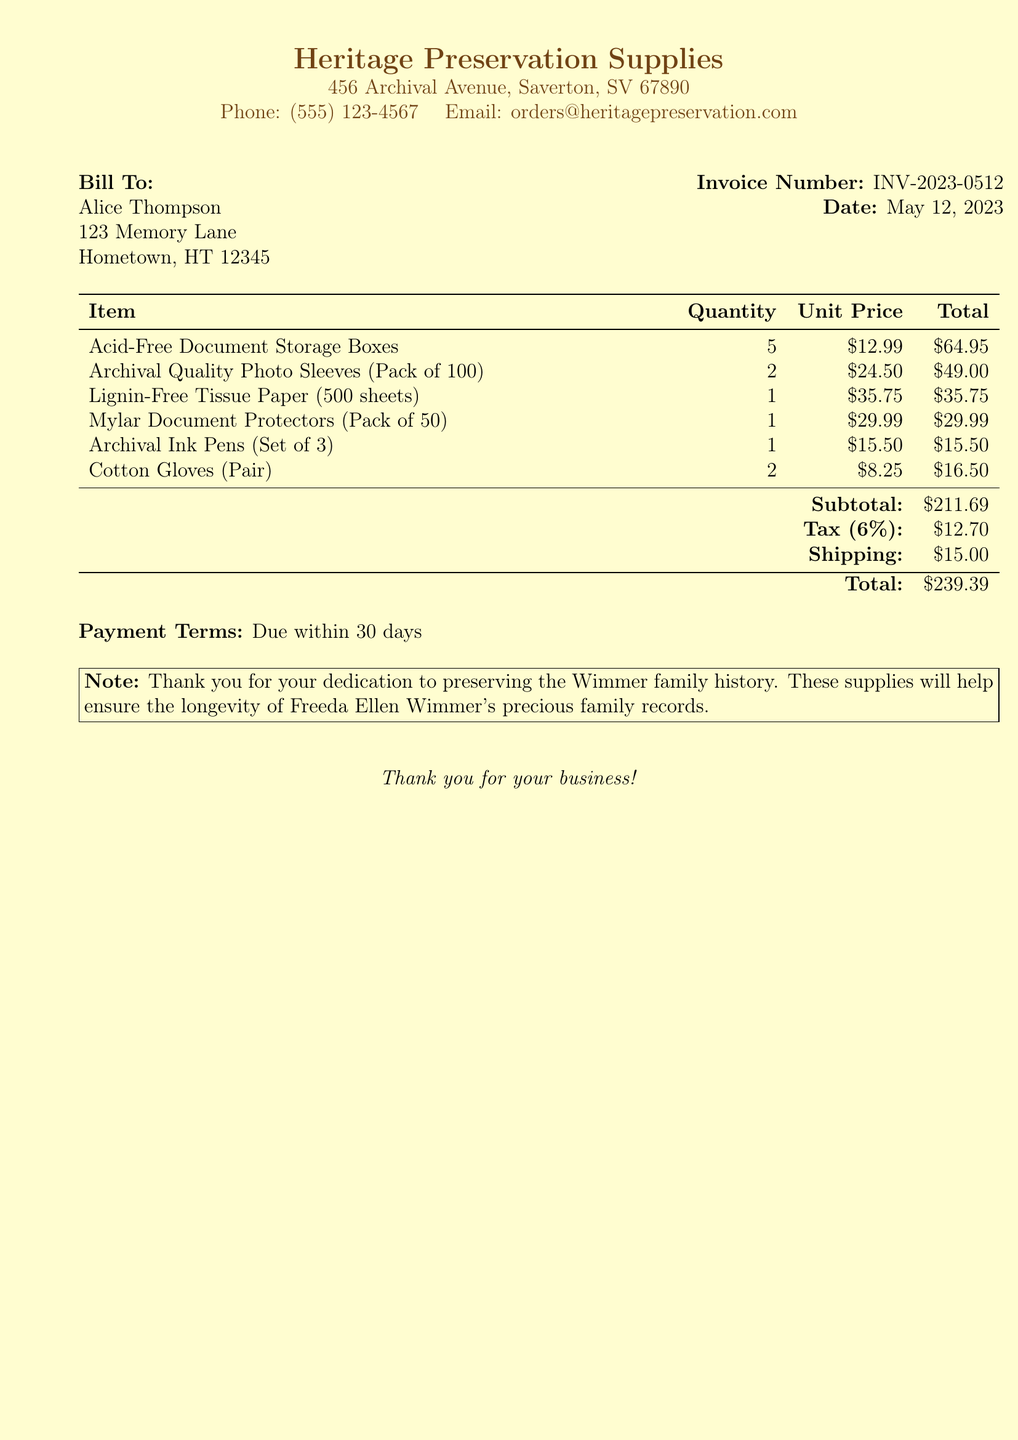What is the invoice number? The invoice number is clearly listed in the document's header section.
Answer: INV-2023-0512 What is the date of the invoice? The date is indicated next to the invoice number in the header section of the document.
Answer: May 12, 2023 Who is the bill to? The document specifies the name and address of the person being billed at the beginning.
Answer: Alice Thompson What is the total amount due? The total amount is calculated at the bottom of the itemized list and includes all fees.
Answer: $239.39 How many cotton gloves were ordered? The quantity of cotton gloves is mentioned in the itemized list of products in the document.
Answer: 2 What item has the highest unit price? The item list shows each unit price, and the highest is identifiable by comparison.
Answer: Lignin-Free Tissue Paper What percentage is the tax? The document indicates tax is calculated based on a specific percentage listed.
Answer: 6% What is the subtotal before tax and shipping? The subtotal is the sum of all item totals before additional charges, which is shown in the summary.
Answer: $211.69 What is the shipping cost? The shipping cost is clearly stated in the summary section of the invoice.
Answer: $15.00 